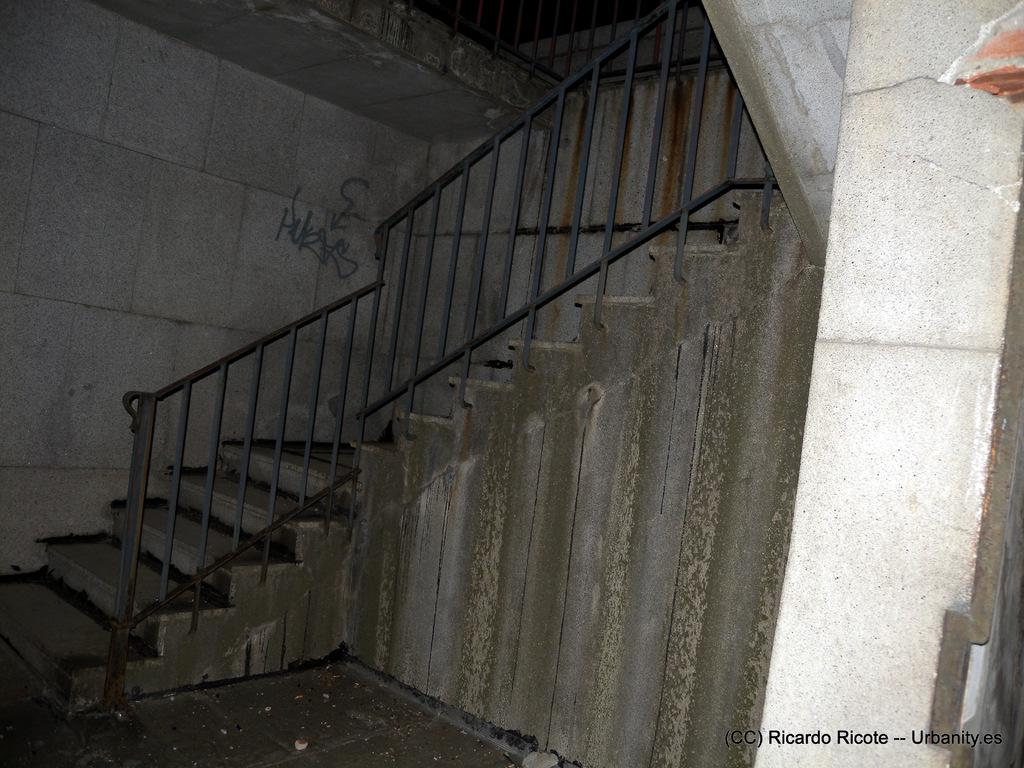What type of structure is present in the image? There is a staircase in the image. What feature is present alongside the staircase? There is a hand railing in the image. What else can be seen in the image? There is a wall in the image. Is there any text visible in the image? Yes, there is text on the wall in the background of the image. What type of oil is being used to wash the cap in the image? There is no oil or cap present in the image, so it is not possible to answer that question. 